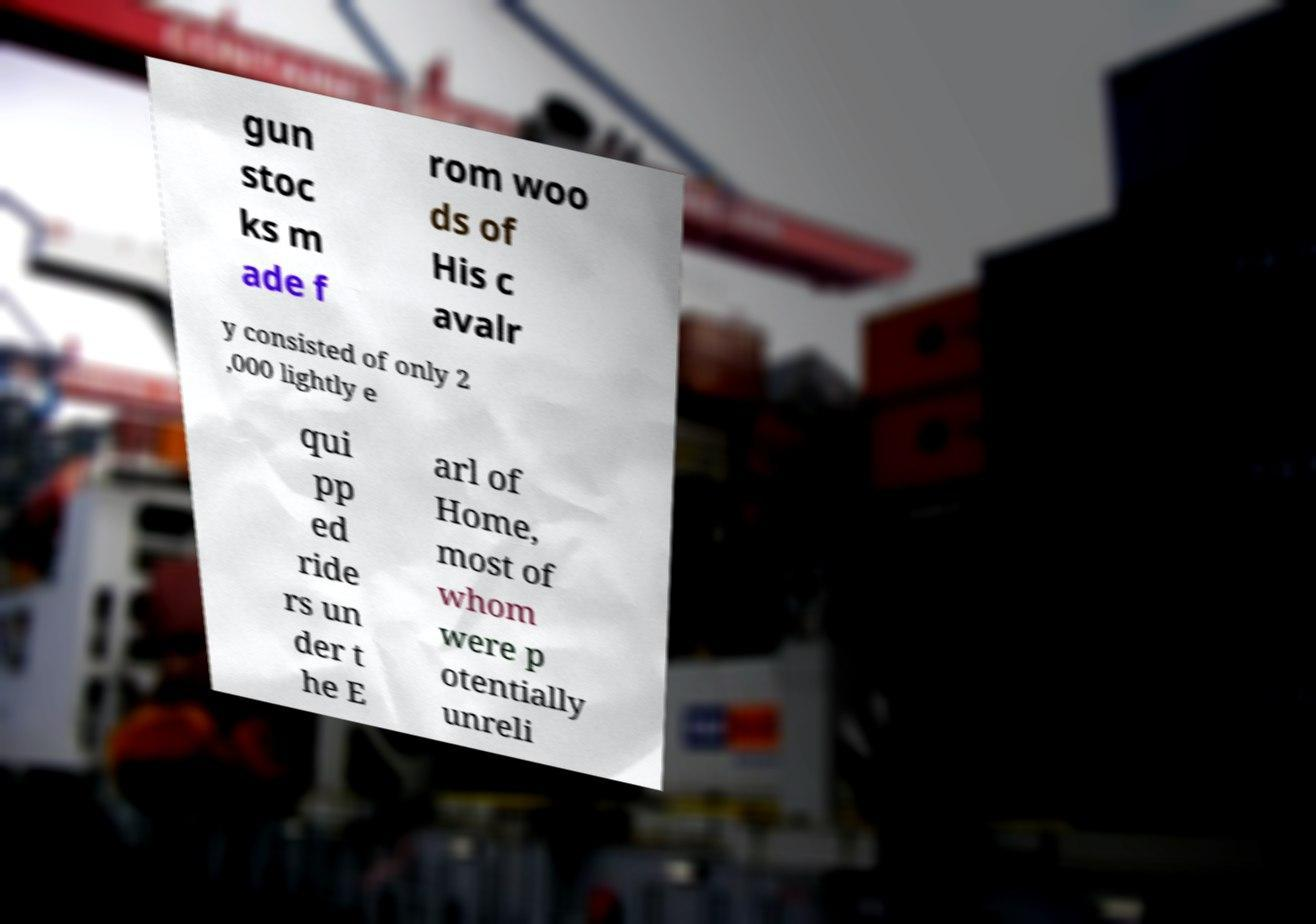Please identify and transcribe the text found in this image. gun stoc ks m ade f rom woo ds of His c avalr y consisted of only 2 ,000 lightly e qui pp ed ride rs un der t he E arl of Home, most of whom were p otentially unreli 